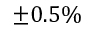<formula> <loc_0><loc_0><loc_500><loc_500>\pm 0 . 5 \%</formula> 